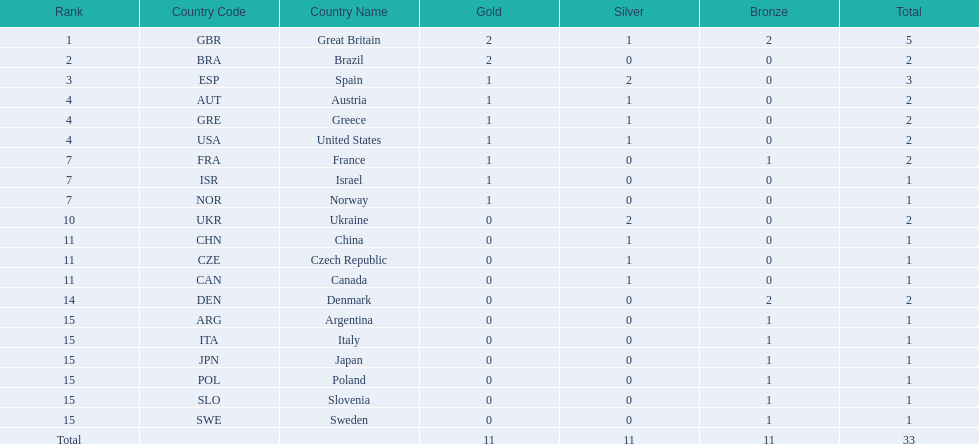Which nation received 2 silver medals? Spain (ESP), Ukraine (UKR). Of those, which nation also had 2 total medals? Spain (ESP). 